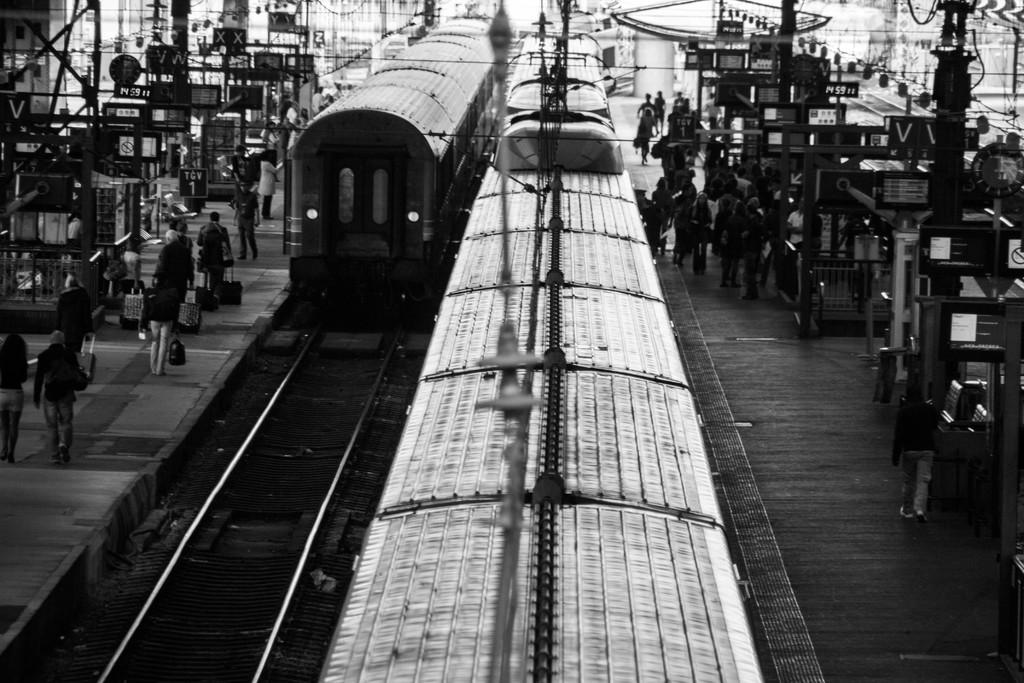What type of vehicles are on the tracks in the image? There are trains on the tracks in the image. What can be seen near the tracks in the image? There are people on the platform in the image. How does the lawyer help the leaf in the image? There is no lawyer or leaf present in the image. 